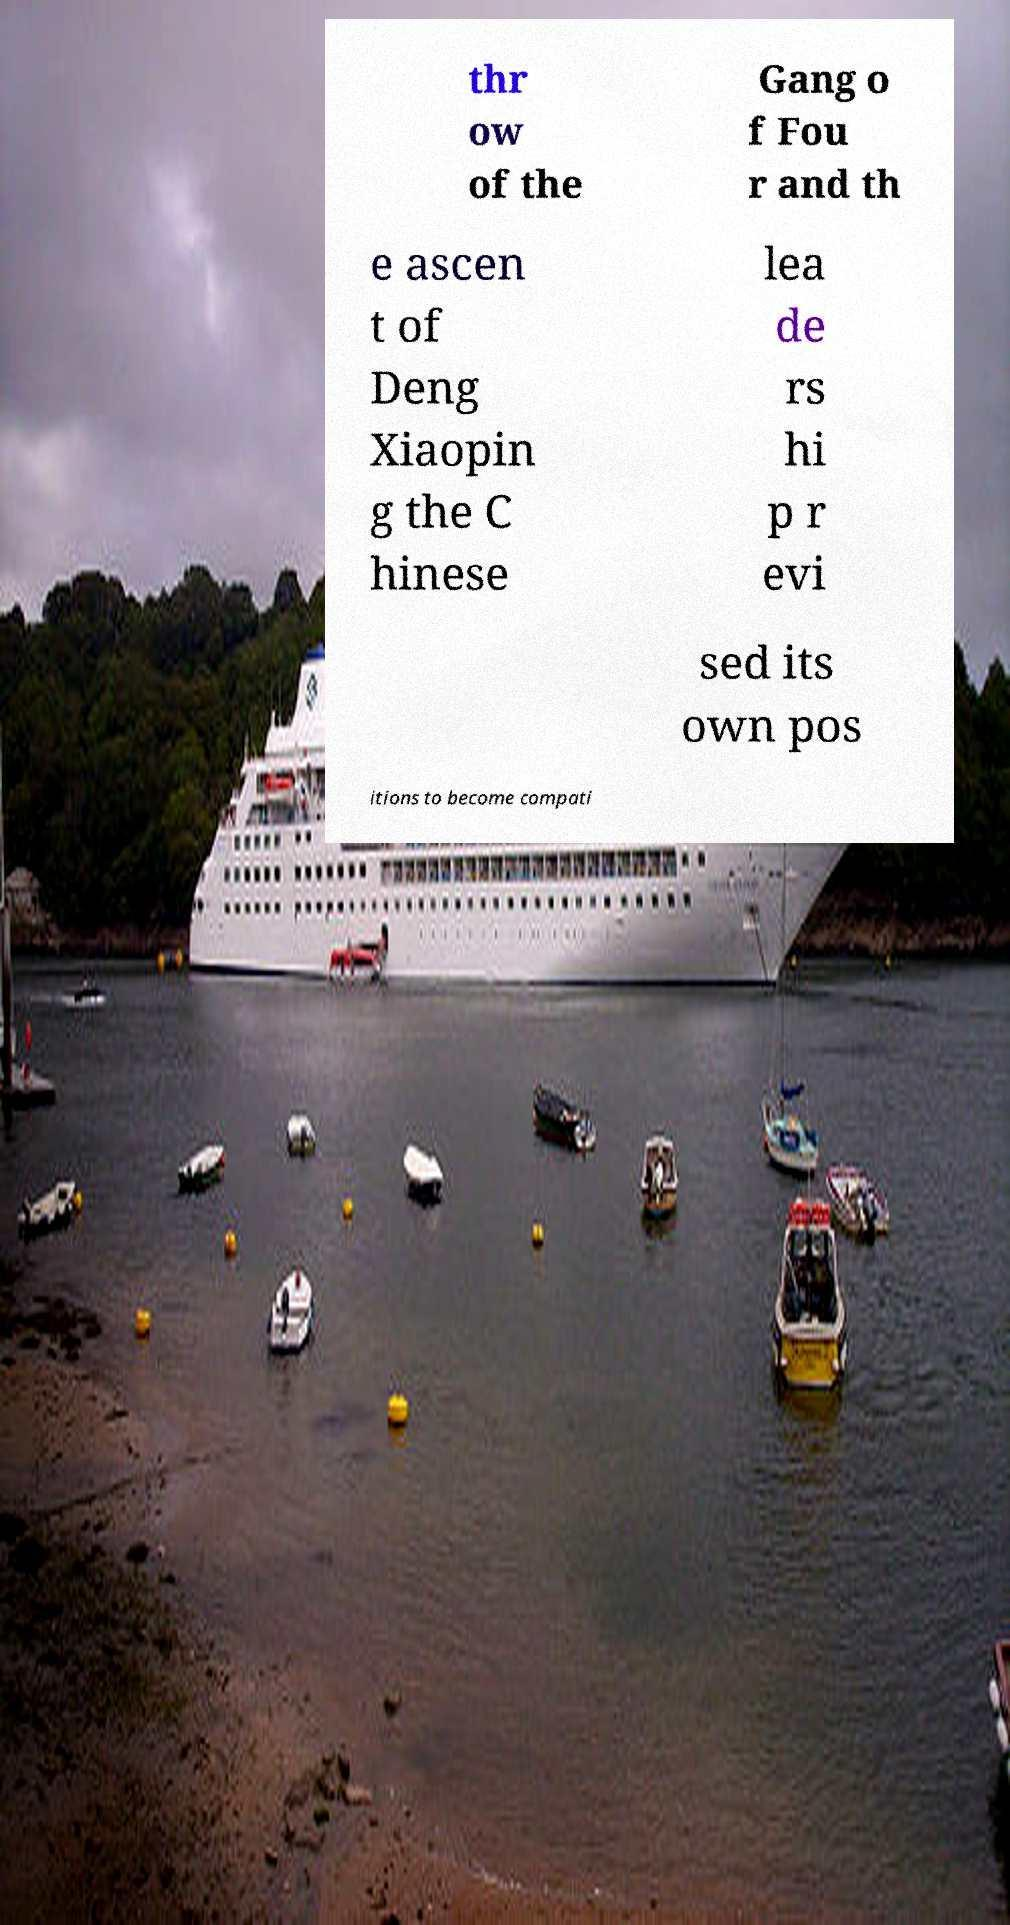Please identify and transcribe the text found in this image. thr ow of the Gang o f Fou r and th e ascen t of Deng Xiaopin g the C hinese lea de rs hi p r evi sed its own pos itions to become compati 